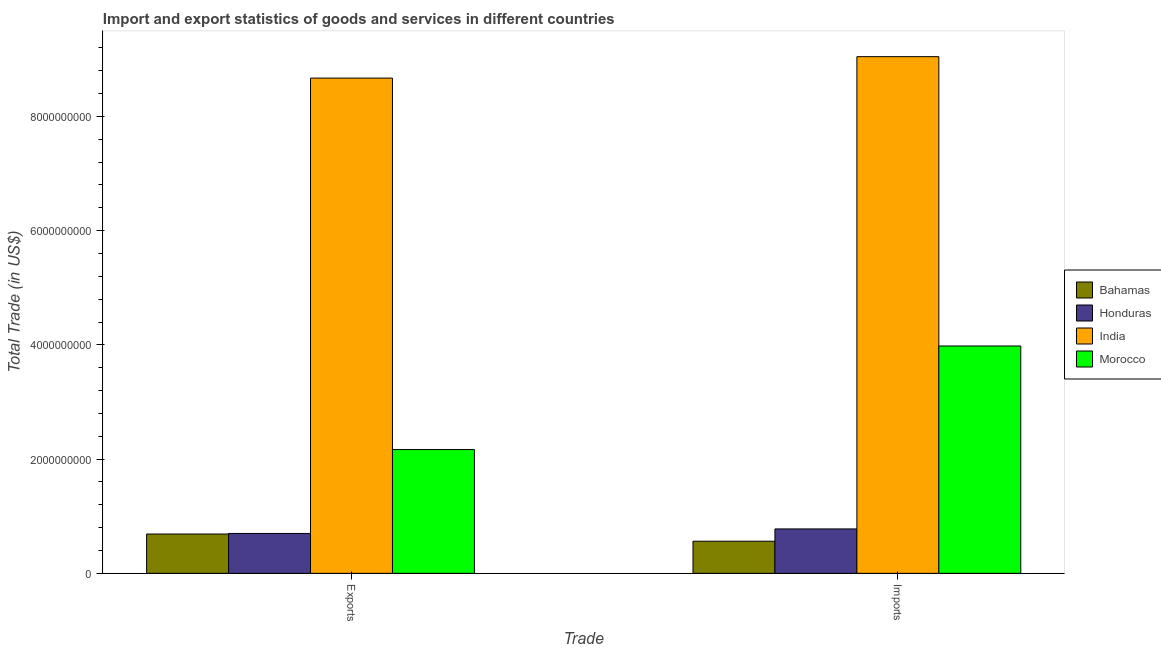How many groups of bars are there?
Give a very brief answer. 2. Are the number of bars per tick equal to the number of legend labels?
Keep it short and to the point. Yes. Are the number of bars on each tick of the X-axis equal?
Provide a succinct answer. Yes. How many bars are there on the 2nd tick from the left?
Ensure brevity in your answer.  4. How many bars are there on the 2nd tick from the right?
Your answer should be compact. 4. What is the label of the 2nd group of bars from the left?
Your answer should be compact. Imports. What is the export of goods and services in India?
Ensure brevity in your answer.  8.67e+09. Across all countries, what is the maximum export of goods and services?
Your response must be concise. 8.67e+09. Across all countries, what is the minimum export of goods and services?
Give a very brief answer. 6.88e+08. In which country was the export of goods and services maximum?
Your answer should be very brief. India. In which country was the export of goods and services minimum?
Offer a very short reply. Bahamas. What is the total export of goods and services in the graph?
Your answer should be compact. 1.22e+1. What is the difference between the export of goods and services in Bahamas and that in India?
Your answer should be compact. -7.98e+09. What is the difference between the export of goods and services in Morocco and the imports of goods and services in India?
Your response must be concise. -6.88e+09. What is the average imports of goods and services per country?
Provide a succinct answer. 3.59e+09. What is the difference between the imports of goods and services and export of goods and services in Bahamas?
Make the answer very short. -1.26e+08. In how many countries, is the imports of goods and services greater than 1600000000 US$?
Your response must be concise. 2. What is the ratio of the imports of goods and services in India to that in Morocco?
Your answer should be very brief. 2.27. Is the imports of goods and services in India less than that in Honduras?
Make the answer very short. No. In how many countries, is the imports of goods and services greater than the average imports of goods and services taken over all countries?
Make the answer very short. 2. What does the 4th bar from the left in Imports represents?
Offer a terse response. Morocco. What does the 2nd bar from the right in Imports represents?
Provide a succinct answer. India. Are all the bars in the graph horizontal?
Keep it short and to the point. No. How many countries are there in the graph?
Provide a succinct answer. 4. Does the graph contain grids?
Your answer should be compact. No. Where does the legend appear in the graph?
Provide a short and direct response. Center right. What is the title of the graph?
Your response must be concise. Import and export statistics of goods and services in different countries. What is the label or title of the X-axis?
Your answer should be very brief. Trade. What is the label or title of the Y-axis?
Your answer should be compact. Total Trade (in US$). What is the Total Trade (in US$) in Bahamas in Exports?
Ensure brevity in your answer.  6.88e+08. What is the Total Trade (in US$) of Honduras in Exports?
Offer a very short reply. 6.98e+08. What is the Total Trade (in US$) of India in Exports?
Provide a succinct answer. 8.67e+09. What is the Total Trade (in US$) of Morocco in Exports?
Provide a succinct answer. 2.17e+09. What is the Total Trade (in US$) of Bahamas in Imports?
Your response must be concise. 5.62e+08. What is the Total Trade (in US$) of Honduras in Imports?
Keep it short and to the point. 7.78e+08. What is the Total Trade (in US$) of India in Imports?
Provide a succinct answer. 9.05e+09. What is the Total Trade (in US$) of Morocco in Imports?
Ensure brevity in your answer.  3.98e+09. Across all Trade, what is the maximum Total Trade (in US$) of Bahamas?
Your answer should be compact. 6.88e+08. Across all Trade, what is the maximum Total Trade (in US$) in Honduras?
Your answer should be compact. 7.78e+08. Across all Trade, what is the maximum Total Trade (in US$) in India?
Your response must be concise. 9.05e+09. Across all Trade, what is the maximum Total Trade (in US$) in Morocco?
Offer a very short reply. 3.98e+09. Across all Trade, what is the minimum Total Trade (in US$) in Bahamas?
Give a very brief answer. 5.62e+08. Across all Trade, what is the minimum Total Trade (in US$) in Honduras?
Ensure brevity in your answer.  6.98e+08. Across all Trade, what is the minimum Total Trade (in US$) in India?
Your answer should be very brief. 8.67e+09. Across all Trade, what is the minimum Total Trade (in US$) in Morocco?
Provide a short and direct response. 2.17e+09. What is the total Total Trade (in US$) in Bahamas in the graph?
Ensure brevity in your answer.  1.25e+09. What is the total Total Trade (in US$) of Honduras in the graph?
Keep it short and to the point. 1.48e+09. What is the total Total Trade (in US$) in India in the graph?
Your response must be concise. 1.77e+1. What is the total Total Trade (in US$) in Morocco in the graph?
Offer a very short reply. 6.15e+09. What is the difference between the Total Trade (in US$) in Bahamas in Exports and that in Imports?
Your answer should be compact. 1.26e+08. What is the difference between the Total Trade (in US$) of Honduras in Exports and that in Imports?
Offer a terse response. -7.95e+07. What is the difference between the Total Trade (in US$) of India in Exports and that in Imports?
Provide a succinct answer. -3.75e+08. What is the difference between the Total Trade (in US$) of Morocco in Exports and that in Imports?
Your answer should be compact. -1.81e+09. What is the difference between the Total Trade (in US$) in Bahamas in Exports and the Total Trade (in US$) in Honduras in Imports?
Give a very brief answer. -8.94e+07. What is the difference between the Total Trade (in US$) in Bahamas in Exports and the Total Trade (in US$) in India in Imports?
Offer a terse response. -8.36e+09. What is the difference between the Total Trade (in US$) of Bahamas in Exports and the Total Trade (in US$) of Morocco in Imports?
Give a very brief answer. -3.29e+09. What is the difference between the Total Trade (in US$) in Honduras in Exports and the Total Trade (in US$) in India in Imports?
Your answer should be compact. -8.35e+09. What is the difference between the Total Trade (in US$) in Honduras in Exports and the Total Trade (in US$) in Morocco in Imports?
Provide a succinct answer. -3.28e+09. What is the difference between the Total Trade (in US$) in India in Exports and the Total Trade (in US$) in Morocco in Imports?
Offer a terse response. 4.69e+09. What is the average Total Trade (in US$) in Bahamas per Trade?
Offer a very short reply. 6.25e+08. What is the average Total Trade (in US$) in Honduras per Trade?
Your answer should be compact. 7.38e+08. What is the average Total Trade (in US$) of India per Trade?
Your answer should be compact. 8.86e+09. What is the average Total Trade (in US$) of Morocco per Trade?
Offer a very short reply. 3.07e+09. What is the difference between the Total Trade (in US$) in Bahamas and Total Trade (in US$) in Honduras in Exports?
Your answer should be very brief. -9.90e+06. What is the difference between the Total Trade (in US$) in Bahamas and Total Trade (in US$) in India in Exports?
Provide a succinct answer. -7.98e+09. What is the difference between the Total Trade (in US$) of Bahamas and Total Trade (in US$) of Morocco in Exports?
Provide a succinct answer. -1.48e+09. What is the difference between the Total Trade (in US$) in Honduras and Total Trade (in US$) in India in Exports?
Your answer should be compact. -7.97e+09. What is the difference between the Total Trade (in US$) of Honduras and Total Trade (in US$) of Morocco in Exports?
Your answer should be very brief. -1.47e+09. What is the difference between the Total Trade (in US$) in India and Total Trade (in US$) in Morocco in Exports?
Offer a very short reply. 6.50e+09. What is the difference between the Total Trade (in US$) in Bahamas and Total Trade (in US$) in Honduras in Imports?
Keep it short and to the point. -2.16e+08. What is the difference between the Total Trade (in US$) in Bahamas and Total Trade (in US$) in India in Imports?
Your answer should be compact. -8.48e+09. What is the difference between the Total Trade (in US$) of Bahamas and Total Trade (in US$) of Morocco in Imports?
Provide a succinct answer. -3.42e+09. What is the difference between the Total Trade (in US$) in Honduras and Total Trade (in US$) in India in Imports?
Provide a succinct answer. -8.27e+09. What is the difference between the Total Trade (in US$) in Honduras and Total Trade (in US$) in Morocco in Imports?
Keep it short and to the point. -3.20e+09. What is the difference between the Total Trade (in US$) in India and Total Trade (in US$) in Morocco in Imports?
Your response must be concise. 5.07e+09. What is the ratio of the Total Trade (in US$) of Bahamas in Exports to that in Imports?
Your answer should be very brief. 1.22. What is the ratio of the Total Trade (in US$) in Honduras in Exports to that in Imports?
Ensure brevity in your answer.  0.9. What is the ratio of the Total Trade (in US$) of India in Exports to that in Imports?
Your answer should be very brief. 0.96. What is the ratio of the Total Trade (in US$) of Morocco in Exports to that in Imports?
Your answer should be very brief. 0.54. What is the difference between the highest and the second highest Total Trade (in US$) of Bahamas?
Provide a succinct answer. 1.26e+08. What is the difference between the highest and the second highest Total Trade (in US$) of Honduras?
Give a very brief answer. 7.95e+07. What is the difference between the highest and the second highest Total Trade (in US$) in India?
Keep it short and to the point. 3.75e+08. What is the difference between the highest and the second highest Total Trade (in US$) in Morocco?
Provide a succinct answer. 1.81e+09. What is the difference between the highest and the lowest Total Trade (in US$) of Bahamas?
Provide a succinct answer. 1.26e+08. What is the difference between the highest and the lowest Total Trade (in US$) of Honduras?
Give a very brief answer. 7.95e+07. What is the difference between the highest and the lowest Total Trade (in US$) in India?
Keep it short and to the point. 3.75e+08. What is the difference between the highest and the lowest Total Trade (in US$) in Morocco?
Give a very brief answer. 1.81e+09. 